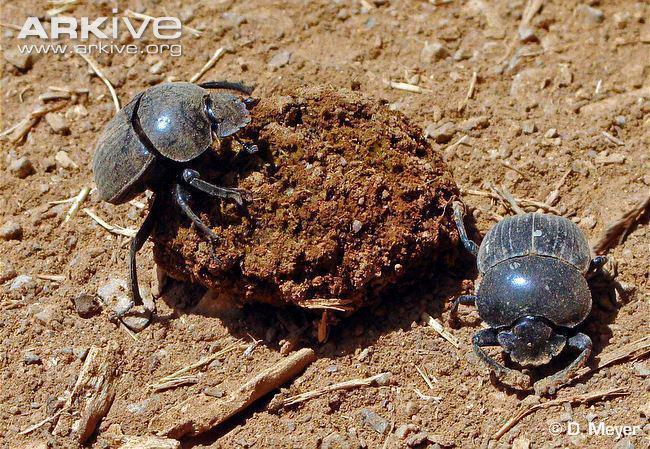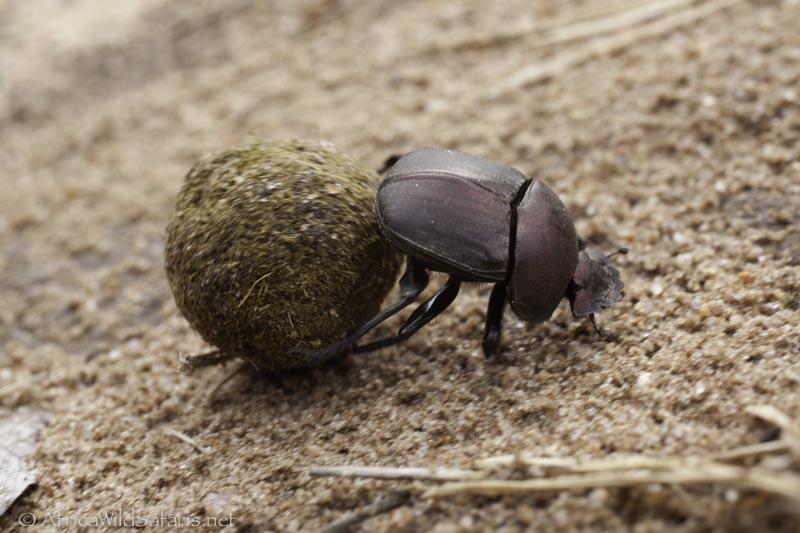The first image is the image on the left, the second image is the image on the right. Assess this claim about the two images: "No rounded, dimensional shape is visible beneath the beetle in the right image.". Correct or not? Answer yes or no. No. The first image is the image on the left, the second image is the image on the right. Given the left and right images, does the statement "There are two beetles on a clod of dirt in one of the images." hold true? Answer yes or no. Yes. 